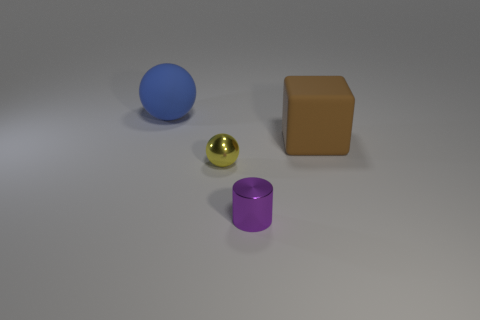Are there an equal number of tiny yellow things behind the big ball and spheres?
Offer a very short reply. No. Do the large matte ball and the small cylinder have the same color?
Provide a short and direct response. No. Is the shape of the big thing that is to the right of the purple object the same as the small thing behind the tiny cylinder?
Give a very brief answer. No. What is the material of the big blue thing that is the same shape as the yellow object?
Your answer should be compact. Rubber. What is the color of the object that is in front of the matte block and behind the purple object?
Provide a succinct answer. Yellow. Is there a tiny yellow sphere that is in front of the shiny object that is on the left side of the tiny shiny thing that is right of the tiny yellow object?
Provide a short and direct response. No. What number of objects are either big brown matte cubes or large cyan matte balls?
Offer a very short reply. 1. Is the big brown thing made of the same material as the large thing that is to the left of the purple metallic object?
Make the answer very short. Yes. Are there any other things that have the same color as the block?
Keep it short and to the point. No. What number of things are metal objects right of the tiny sphere or small purple objects that are right of the tiny shiny sphere?
Your answer should be very brief. 1. 